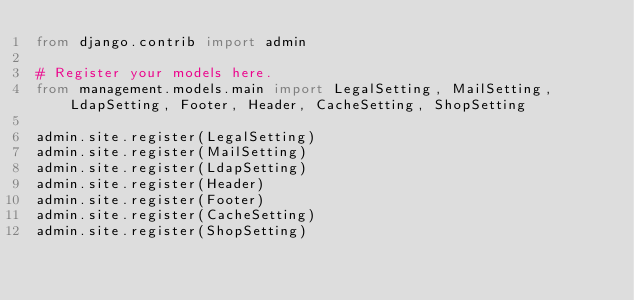<code> <loc_0><loc_0><loc_500><loc_500><_Python_>from django.contrib import admin

# Register your models here.
from management.models.main import LegalSetting, MailSetting, LdapSetting, Footer, Header, CacheSetting, ShopSetting

admin.site.register(LegalSetting)
admin.site.register(MailSetting)
admin.site.register(LdapSetting)
admin.site.register(Header)
admin.site.register(Footer)
admin.site.register(CacheSetting)
admin.site.register(ShopSetting)
</code> 